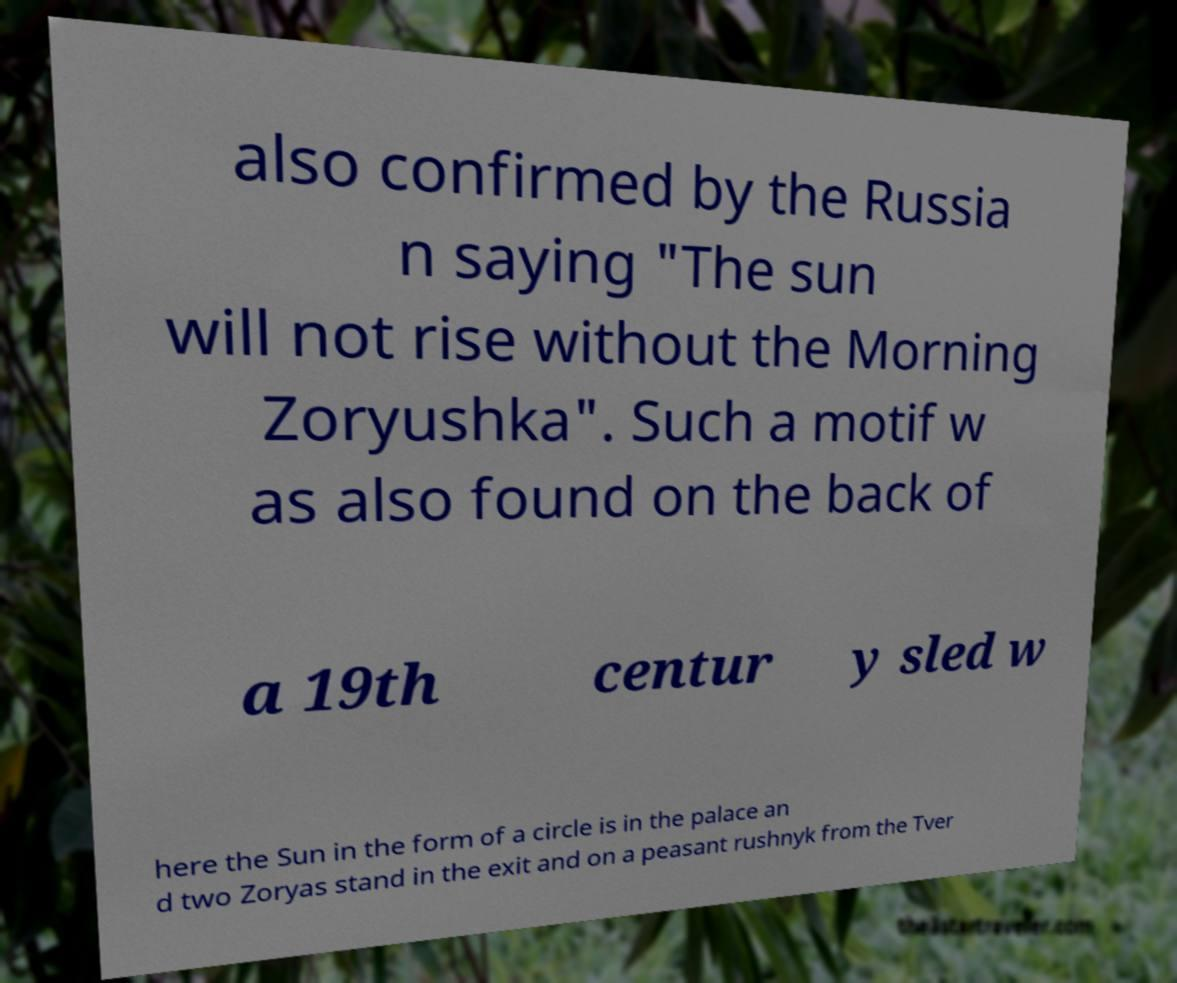Could you extract and type out the text from this image? also confirmed by the Russia n saying "The sun will not rise without the Morning Zoryushka". Such a motif w as also found on the back of a 19th centur y sled w here the Sun in the form of a circle is in the palace an d two Zoryas stand in the exit and on a peasant rushnyk from the Tver 